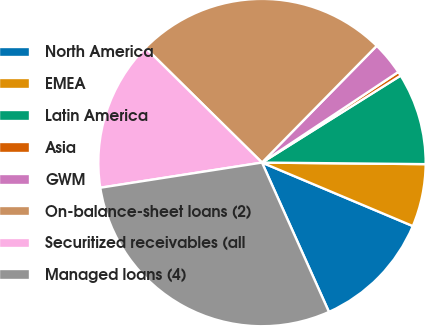Convert chart. <chart><loc_0><loc_0><loc_500><loc_500><pie_chart><fcel>North America<fcel>EMEA<fcel>Latin America<fcel>Asia<fcel>GWM<fcel>On-balance-sheet loans (2)<fcel>Securitized receivables (all<fcel>Managed loans (4)<nl><fcel>11.95%<fcel>6.19%<fcel>9.07%<fcel>0.42%<fcel>3.3%<fcel>24.98%<fcel>14.84%<fcel>29.25%<nl></chart> 